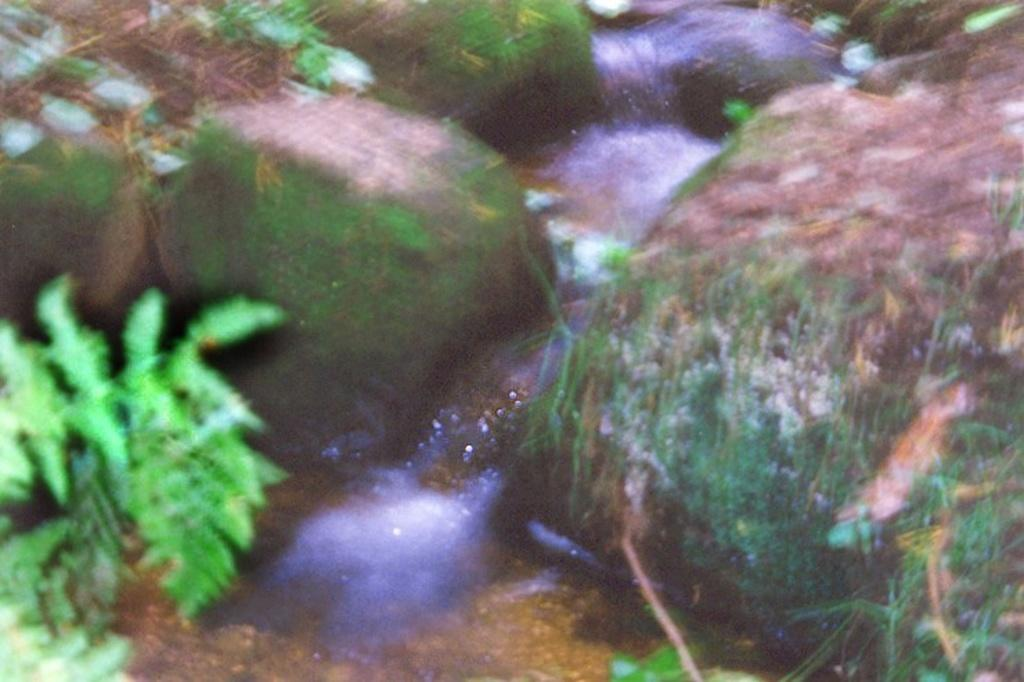What type of living organisms can be seen in the image? Plants can be seen in the image. What natural element is visible in the image? Water is visible in the image. What type of geological formation is present in the image? Rocks are present in the image. What type of lead can be seen in the image? There is no lead present in the image. How many thumbs can be seen in the image? There are no thumbs visible in the image. 